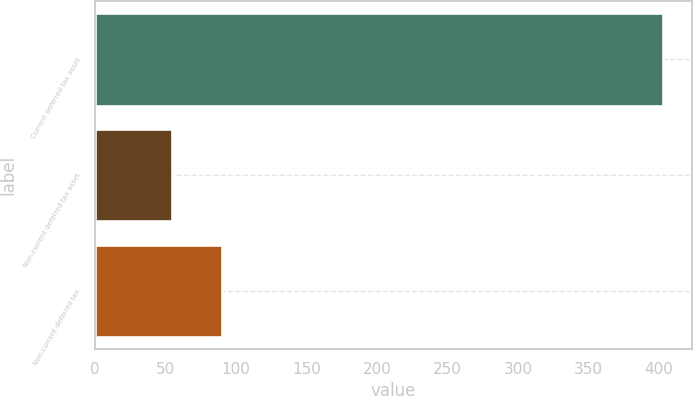<chart> <loc_0><loc_0><loc_500><loc_500><bar_chart><fcel>Current deferred tax asset<fcel>Non-current deferred tax asset<fcel>Non-current deferred tax<nl><fcel>403<fcel>55<fcel>89.8<nl></chart> 